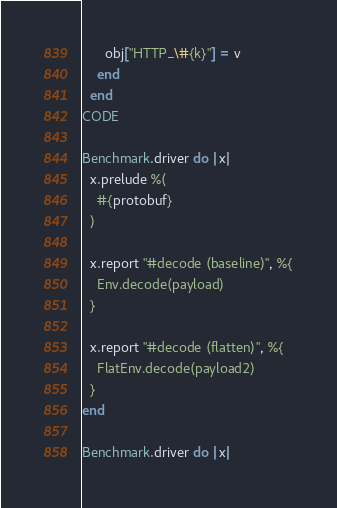<code> <loc_0><loc_0><loc_500><loc_500><_Ruby_>      obj["HTTP_\#{k}"] = v
    end
  end
CODE

Benchmark.driver do |x|
  x.prelude %(
    #{protobuf}
  )

  x.report "#decode (baseline)", %{
    Env.decode(payload)
  }

  x.report "#decode (flatten)", %{
    FlatEnv.decode(payload2)
  }
end

Benchmark.driver do |x|</code> 